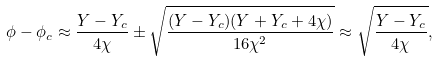Convert formula to latex. <formula><loc_0><loc_0><loc_500><loc_500>\phi - \phi _ { c } \approx \frac { Y - Y _ { c } } { 4 \chi } \pm \sqrt { \frac { ( Y - Y _ { c } ) ( Y + Y _ { c } + 4 \chi ) } { 1 6 \chi ^ { 2 } } } \approx \sqrt { \frac { Y - Y _ { c } } { 4 \chi } } ,</formula> 